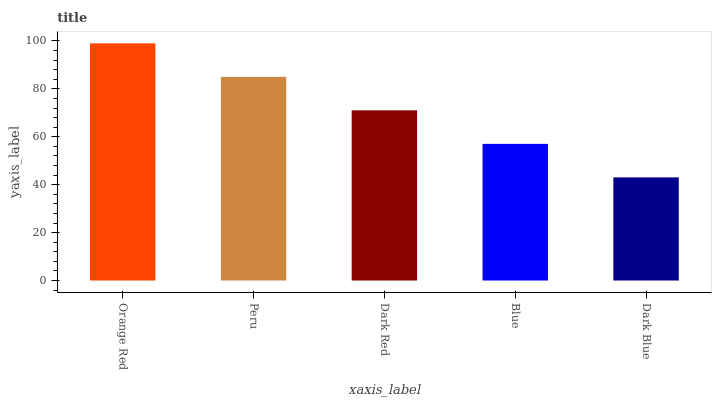Is Dark Blue the minimum?
Answer yes or no. Yes. Is Orange Red the maximum?
Answer yes or no. Yes. Is Peru the minimum?
Answer yes or no. No. Is Peru the maximum?
Answer yes or no. No. Is Orange Red greater than Peru?
Answer yes or no. Yes. Is Peru less than Orange Red?
Answer yes or no. Yes. Is Peru greater than Orange Red?
Answer yes or no. No. Is Orange Red less than Peru?
Answer yes or no. No. Is Dark Red the high median?
Answer yes or no. Yes. Is Dark Red the low median?
Answer yes or no. Yes. Is Blue the high median?
Answer yes or no. No. Is Blue the low median?
Answer yes or no. No. 